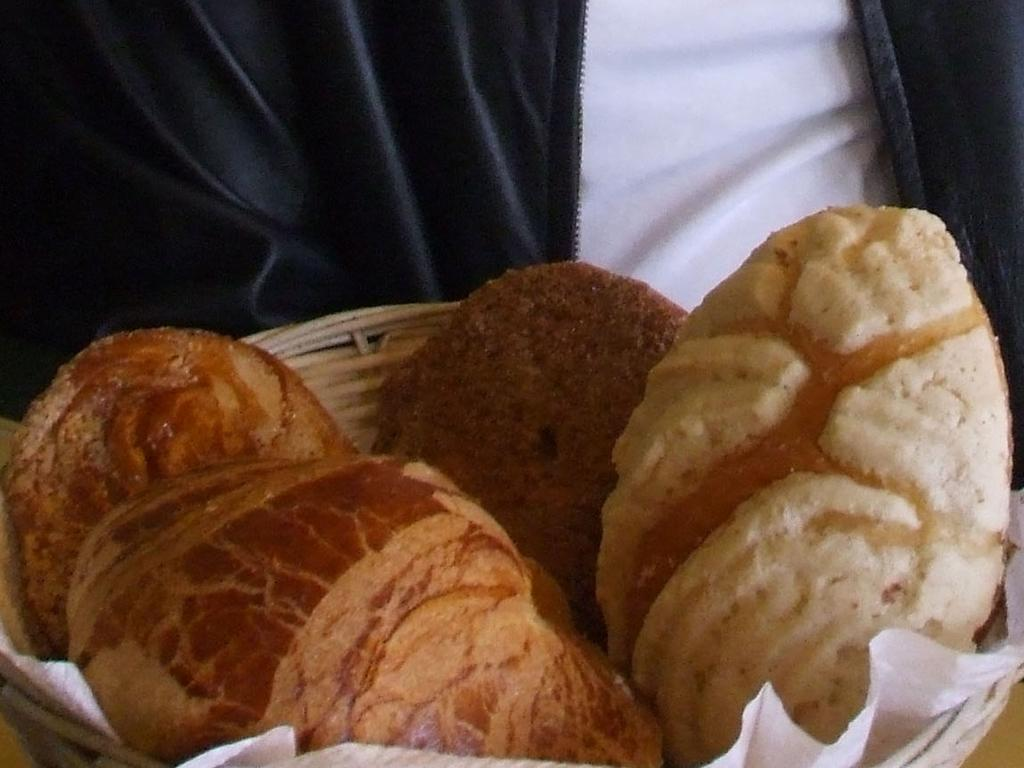What is placed in the basket in the image? There is a food item placed in a basket in the image. Can you describe the person in front of the basket? Unfortunately, the provided facts do not give any information about the person's appearance or actions. What might the person be doing in relation to the food item in the basket? Based on the available information, it is unclear what the person is doing, but they are in front of the basket. How many cannons are present in the image? There are no cannons present in the image. What type of ants can be seen crawling on the food item in the basket? There are no ants present in the image, so it is not possible to determine what type of ants might be crawling on the food item. 